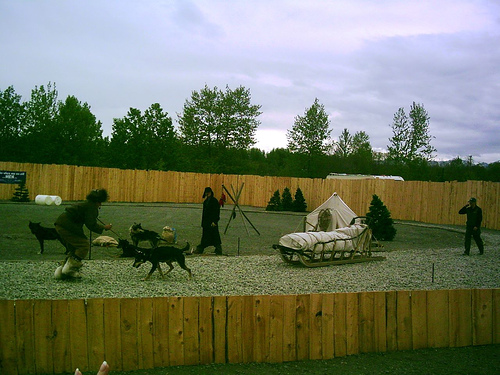What does the presence of people in this image tell us about the relationship between humans and dogs? The people present alongside the dogs suggest a close working relationship steeped in training and partnership. These individuals appear to be trainers or handlers, engaged in directing the dogs or simulating conditions for a sled journey. The mutual coordination and effort depicted here highlight the deep bond and trust between humans and dogs, especially in activities that rely on precise teamwork and communication. 